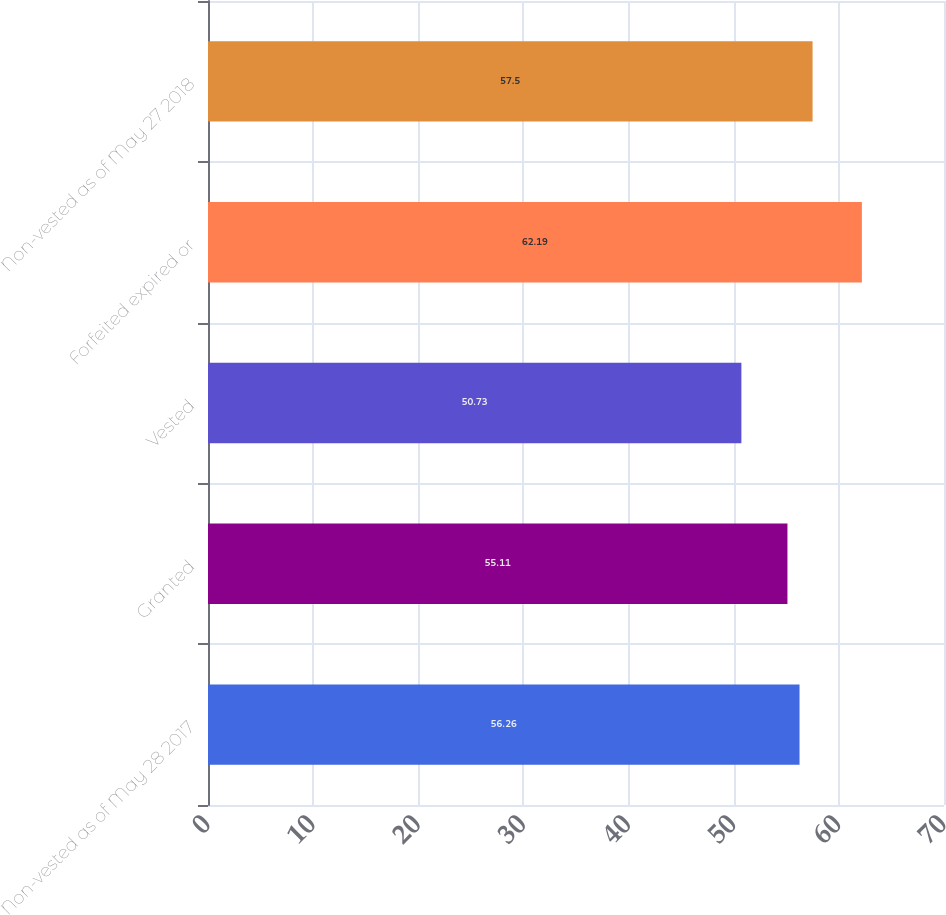<chart> <loc_0><loc_0><loc_500><loc_500><bar_chart><fcel>Non-vested as of May 28 2017<fcel>Granted<fcel>Vested<fcel>Forfeited expired or<fcel>Non-vested as of May 27 2018<nl><fcel>56.26<fcel>55.11<fcel>50.73<fcel>62.19<fcel>57.5<nl></chart> 